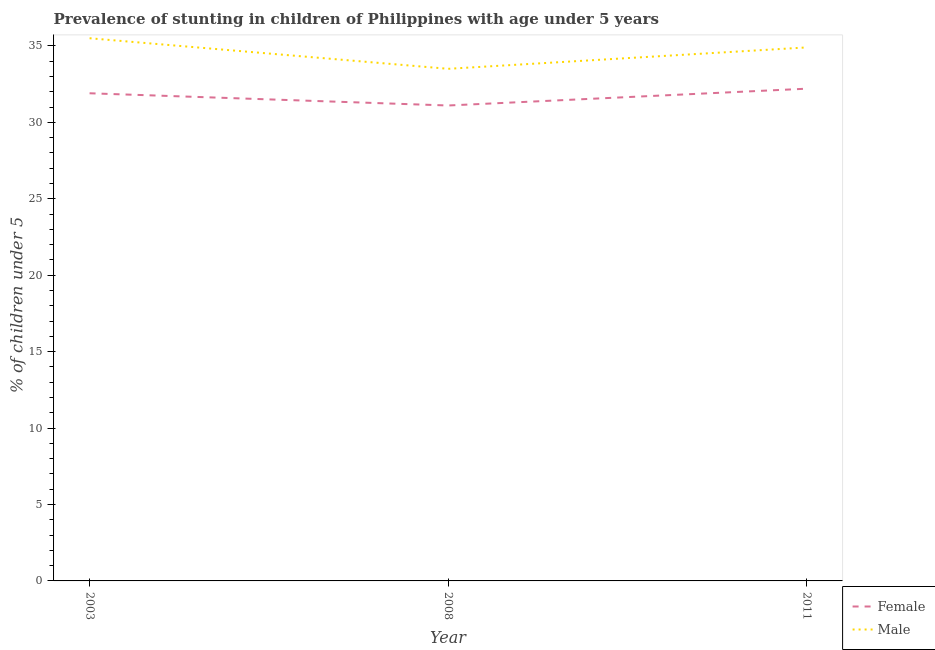How many different coloured lines are there?
Offer a terse response. 2. Is the number of lines equal to the number of legend labels?
Your answer should be compact. Yes. What is the percentage of stunted female children in 2003?
Provide a succinct answer. 31.9. Across all years, what is the maximum percentage of stunted female children?
Your response must be concise. 32.2. Across all years, what is the minimum percentage of stunted female children?
Give a very brief answer. 31.1. In which year was the percentage of stunted female children minimum?
Give a very brief answer. 2008. What is the total percentage of stunted female children in the graph?
Provide a short and direct response. 95.2. What is the difference between the percentage of stunted female children in 2003 and that in 2011?
Your response must be concise. -0.3. What is the difference between the percentage of stunted female children in 2011 and the percentage of stunted male children in 2008?
Provide a short and direct response. -1.3. What is the average percentage of stunted female children per year?
Your answer should be compact. 31.73. In the year 2011, what is the difference between the percentage of stunted male children and percentage of stunted female children?
Your response must be concise. 2.7. What is the ratio of the percentage of stunted female children in 2008 to that in 2011?
Your answer should be very brief. 0.97. What is the difference between the highest and the second highest percentage of stunted female children?
Ensure brevity in your answer.  0.3. What is the difference between the highest and the lowest percentage of stunted male children?
Give a very brief answer. 2. Is the percentage of stunted female children strictly greater than the percentage of stunted male children over the years?
Your response must be concise. No. How many lines are there?
Make the answer very short. 2. Does the graph contain any zero values?
Offer a terse response. No. Does the graph contain grids?
Give a very brief answer. No. Where does the legend appear in the graph?
Your response must be concise. Bottom right. What is the title of the graph?
Make the answer very short. Prevalence of stunting in children of Philippines with age under 5 years. Does "IMF nonconcessional" appear as one of the legend labels in the graph?
Your answer should be very brief. No. What is the label or title of the Y-axis?
Your answer should be compact.  % of children under 5. What is the  % of children under 5 of Female in 2003?
Your answer should be very brief. 31.9. What is the  % of children under 5 in Male in 2003?
Keep it short and to the point. 35.5. What is the  % of children under 5 of Female in 2008?
Ensure brevity in your answer.  31.1. What is the  % of children under 5 in Male in 2008?
Keep it short and to the point. 33.5. What is the  % of children under 5 of Female in 2011?
Provide a short and direct response. 32.2. What is the  % of children under 5 of Male in 2011?
Make the answer very short. 34.9. Across all years, what is the maximum  % of children under 5 of Female?
Make the answer very short. 32.2. Across all years, what is the maximum  % of children under 5 in Male?
Your response must be concise. 35.5. Across all years, what is the minimum  % of children under 5 of Female?
Offer a very short reply. 31.1. Across all years, what is the minimum  % of children under 5 in Male?
Ensure brevity in your answer.  33.5. What is the total  % of children under 5 of Female in the graph?
Ensure brevity in your answer.  95.2. What is the total  % of children under 5 in Male in the graph?
Provide a succinct answer. 103.9. What is the difference between the  % of children under 5 in Male in 2003 and that in 2008?
Offer a very short reply. 2. What is the difference between the  % of children under 5 in Female in 2003 and that in 2011?
Provide a short and direct response. -0.3. What is the difference between the  % of children under 5 in Male in 2003 and that in 2011?
Make the answer very short. 0.6. What is the difference between the  % of children under 5 of Female in 2003 and the  % of children under 5 of Male in 2008?
Ensure brevity in your answer.  -1.6. What is the difference between the  % of children under 5 in Female in 2008 and the  % of children under 5 in Male in 2011?
Make the answer very short. -3.8. What is the average  % of children under 5 in Female per year?
Offer a terse response. 31.73. What is the average  % of children under 5 in Male per year?
Provide a short and direct response. 34.63. In the year 2008, what is the difference between the  % of children under 5 in Female and  % of children under 5 in Male?
Provide a short and direct response. -2.4. In the year 2011, what is the difference between the  % of children under 5 in Female and  % of children under 5 in Male?
Provide a short and direct response. -2.7. What is the ratio of the  % of children under 5 of Female in 2003 to that in 2008?
Provide a succinct answer. 1.03. What is the ratio of the  % of children under 5 of Male in 2003 to that in 2008?
Your answer should be compact. 1.06. What is the ratio of the  % of children under 5 in Male in 2003 to that in 2011?
Offer a terse response. 1.02. What is the ratio of the  % of children under 5 in Female in 2008 to that in 2011?
Give a very brief answer. 0.97. What is the ratio of the  % of children under 5 in Male in 2008 to that in 2011?
Keep it short and to the point. 0.96. What is the difference between the highest and the second highest  % of children under 5 in Female?
Your response must be concise. 0.3. 